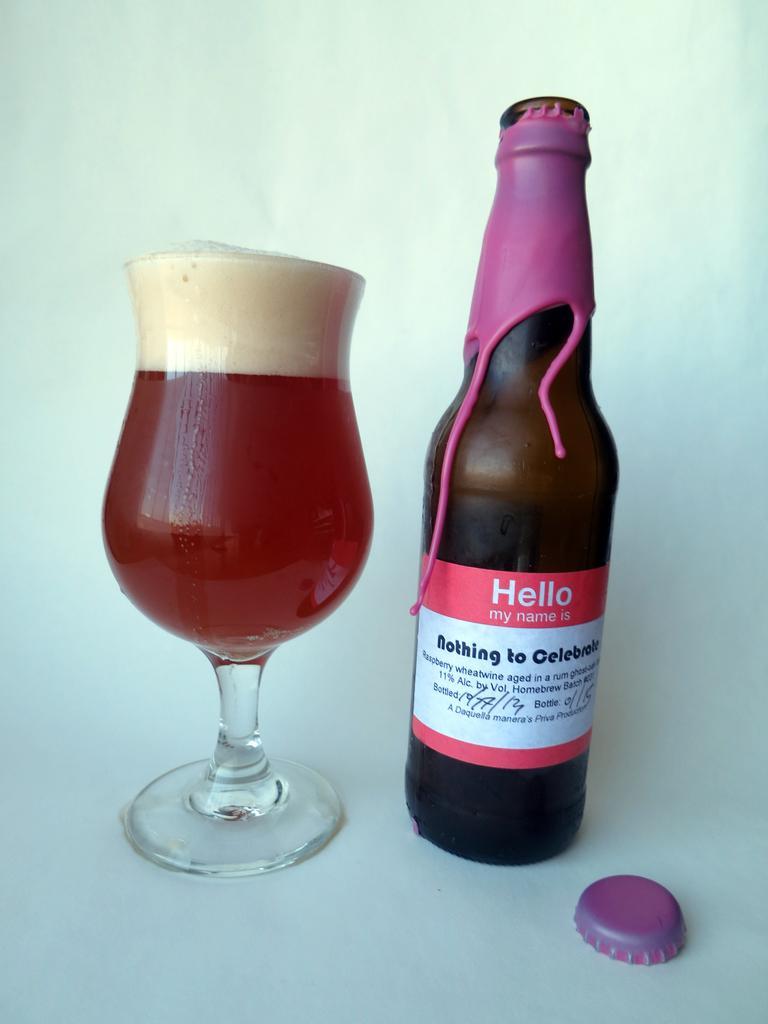Could you give a brief overview of what you see in this image? In this picture we can see a glass with drink in it, beside to the glass we can find a bottle and a bottle cap. 